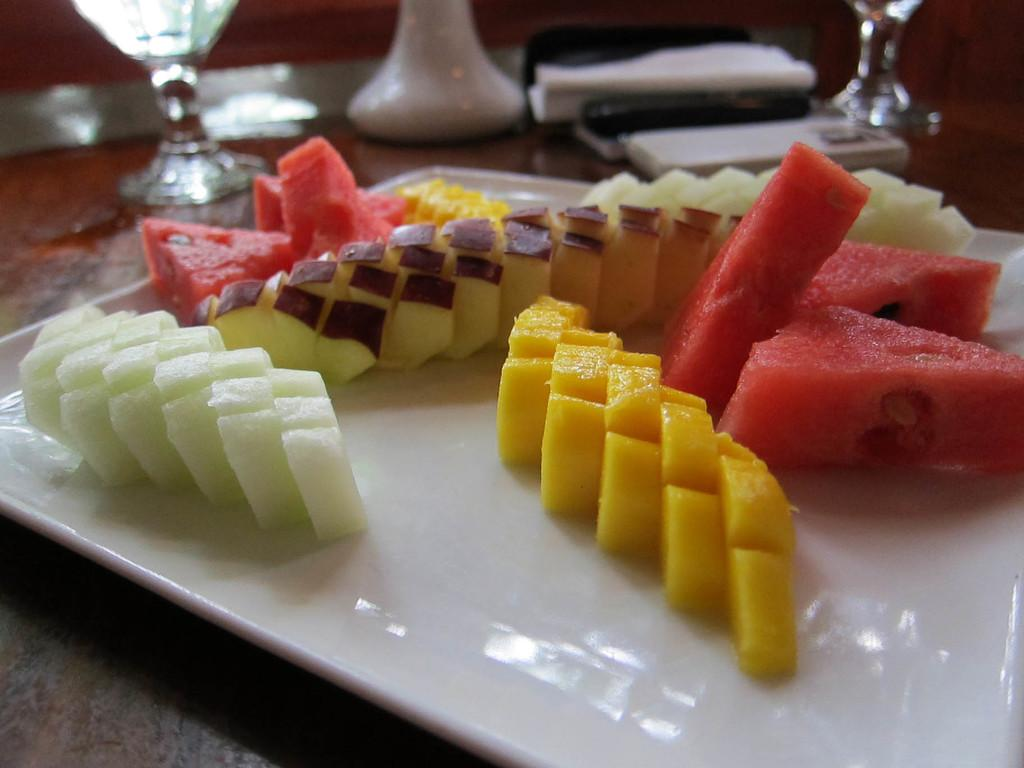What is the main object on the platform in the image? There is a tray in the image. What is on the tray? The tray contains fruit pieces. What else can be seen beside the tray? There are glasses and tissue papers beside the tray. Where are all these items placed? All of these items are placed on a platform. How much payment is required to access the history of the fruit pieces in the image? There is no payment or history related to the fruit pieces in the image; it simply shows a tray with fruit pieces on it. 